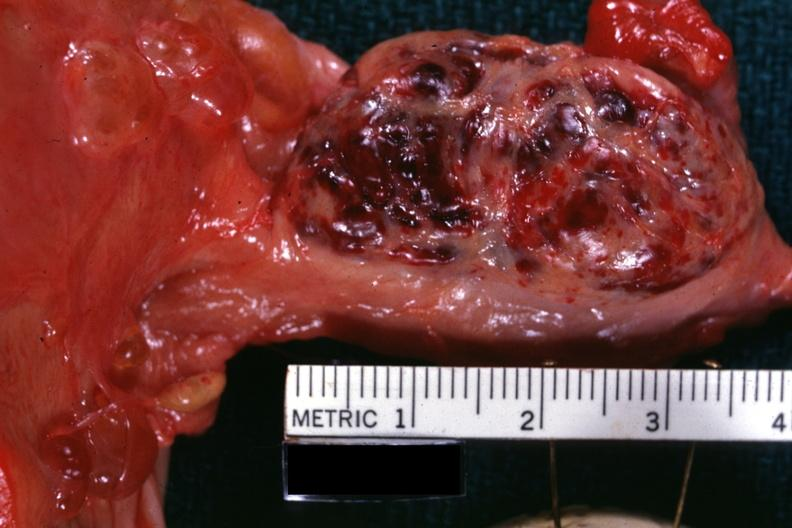s pulmonary osteoarthropathy present?
Answer the question using a single word or phrase. No 